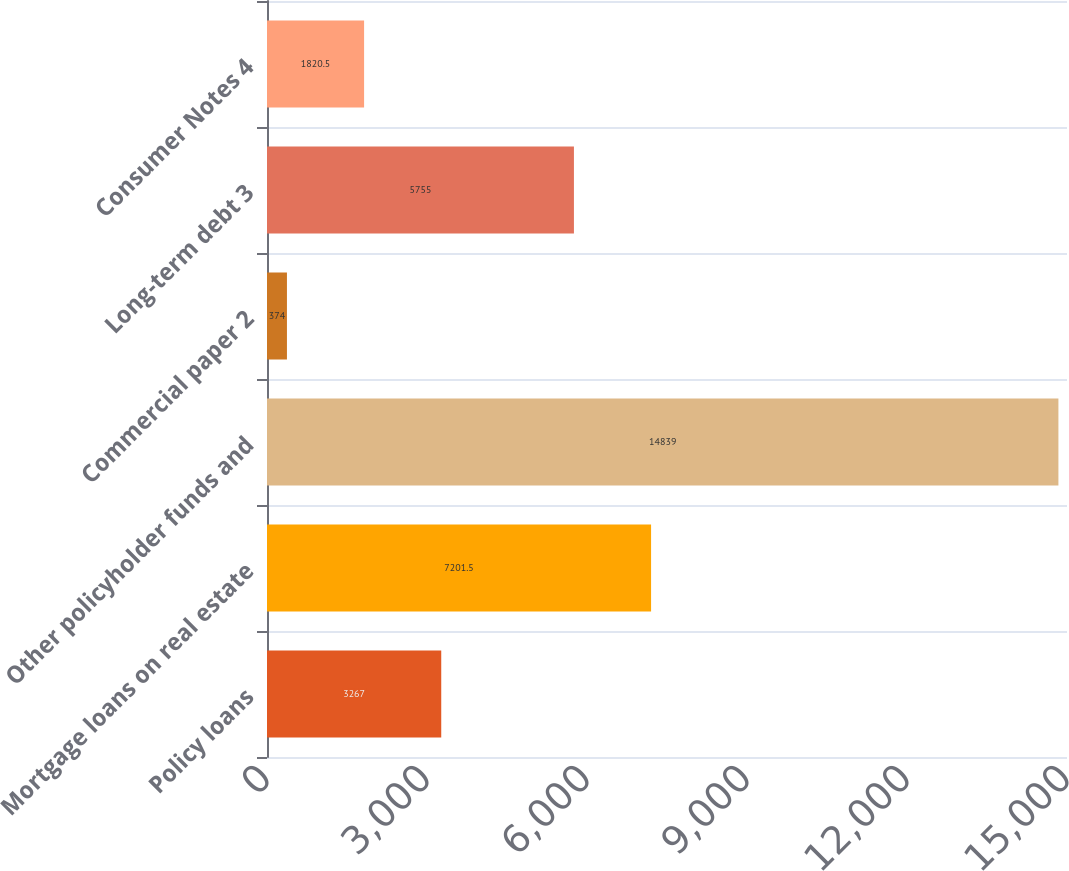<chart> <loc_0><loc_0><loc_500><loc_500><bar_chart><fcel>Policy loans<fcel>Mortgage loans on real estate<fcel>Other policyholder funds and<fcel>Commercial paper 2<fcel>Long-term debt 3<fcel>Consumer Notes 4<nl><fcel>3267<fcel>7201.5<fcel>14839<fcel>374<fcel>5755<fcel>1820.5<nl></chart> 